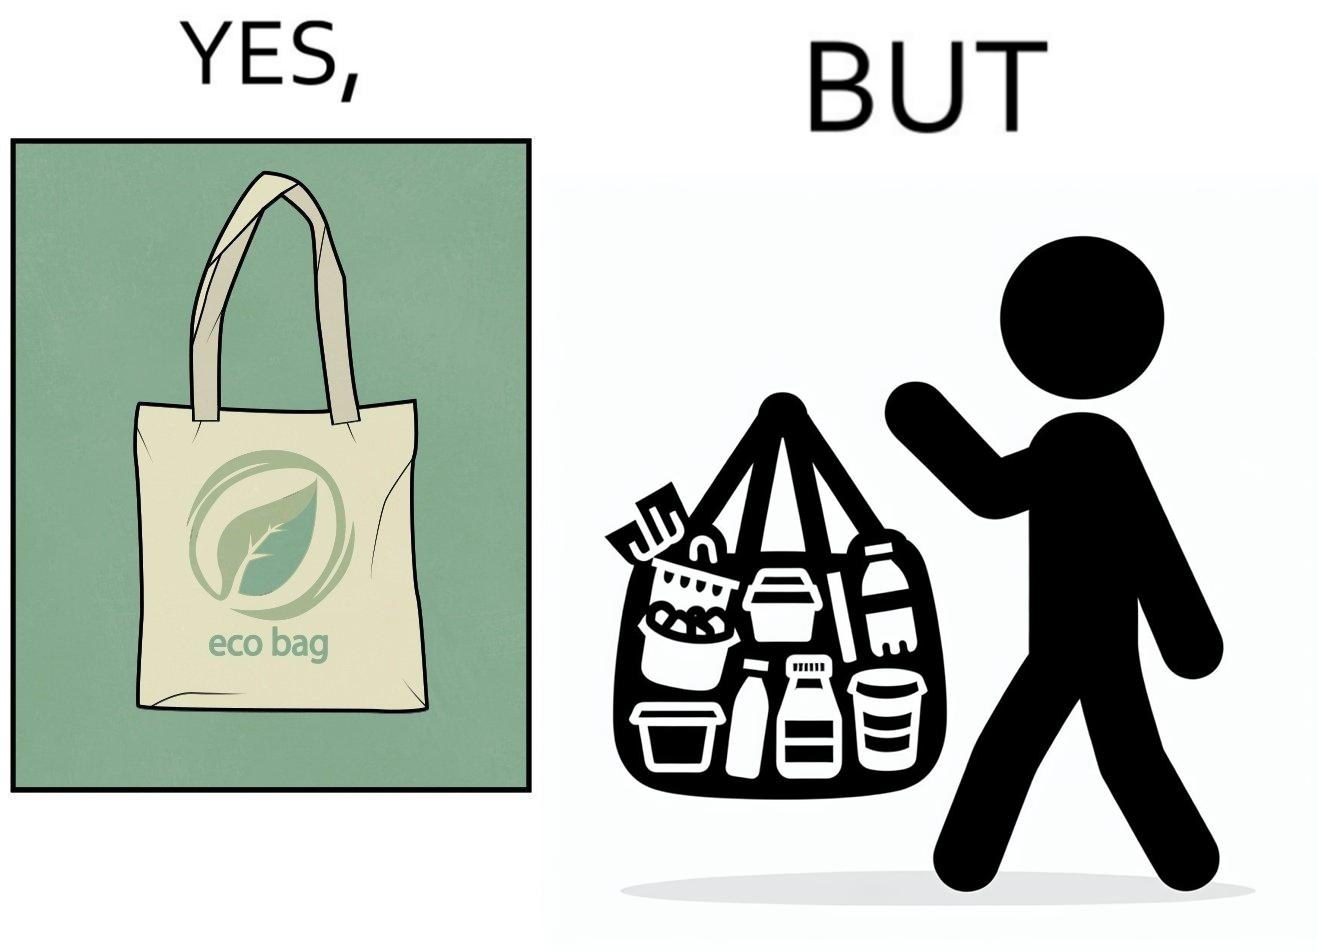Is there satirical content in this image? Yes, this image is satirical. 